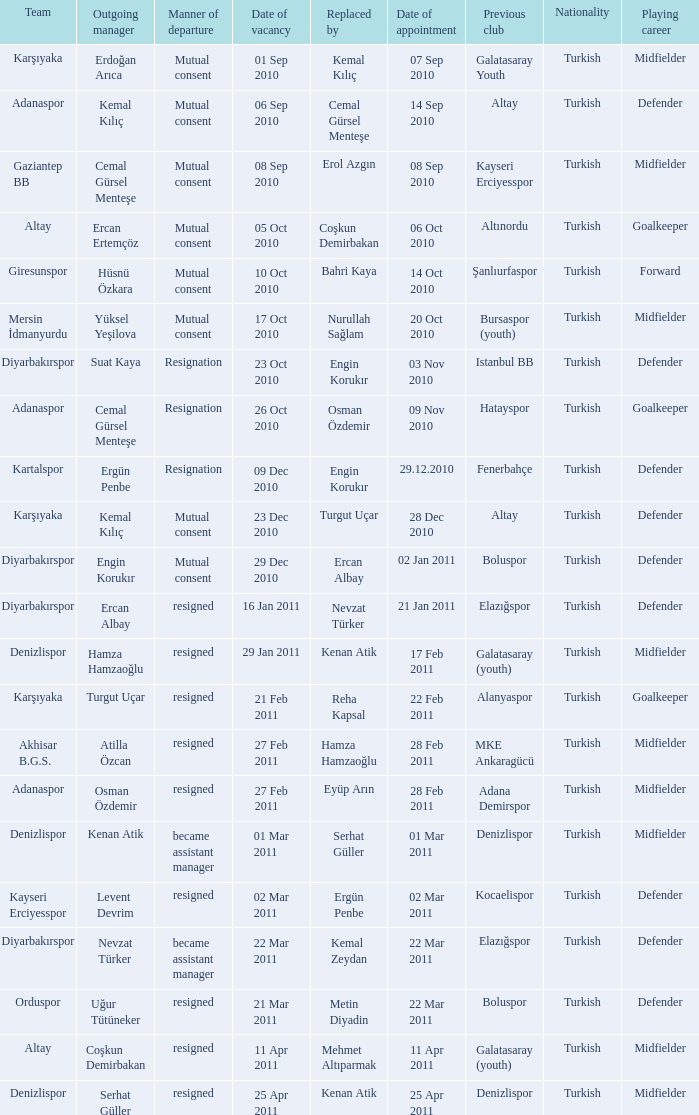Who replaced the outgoing manager Hüsnü Özkara?  Bahri Kaya. 